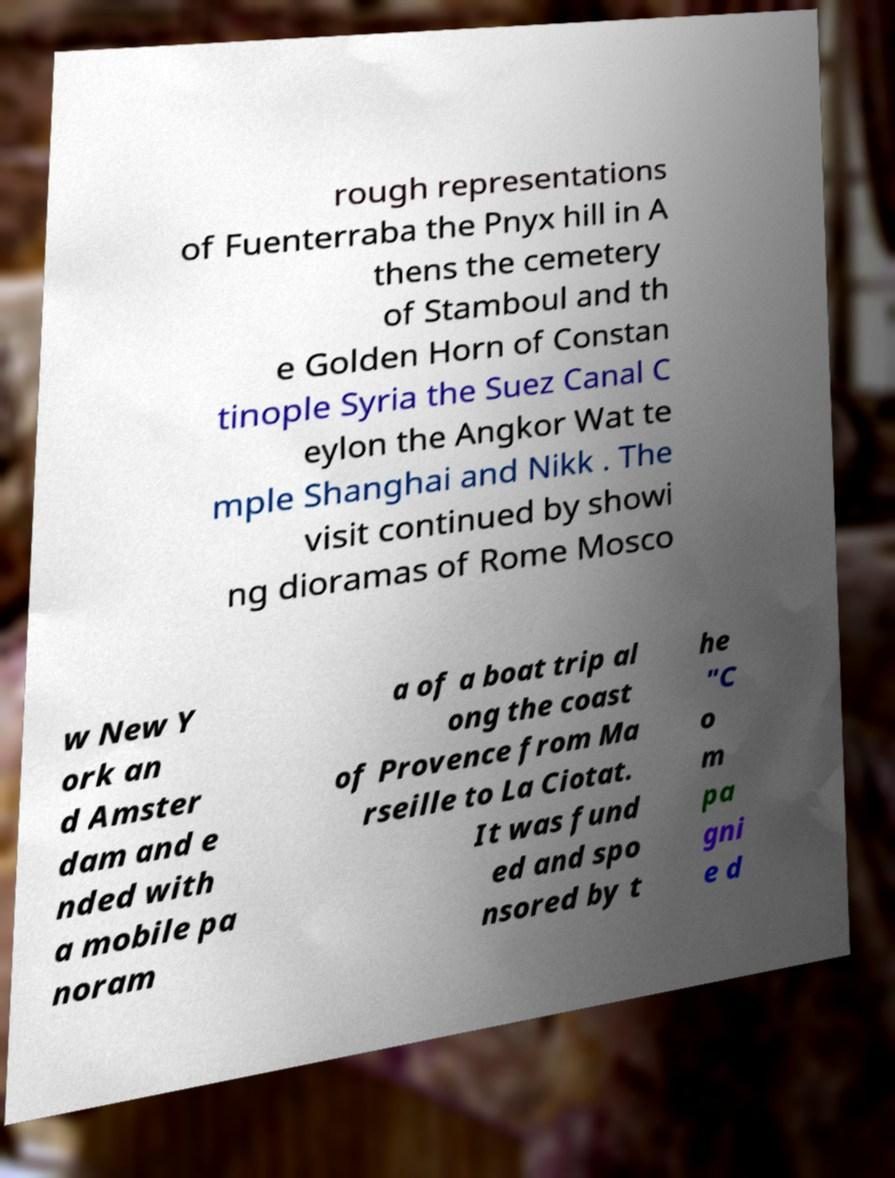I need the written content from this picture converted into text. Can you do that? rough representations of Fuenterraba the Pnyx hill in A thens the cemetery of Stamboul and th e Golden Horn of Constan tinople Syria the Suez Canal C eylon the Angkor Wat te mple Shanghai and Nikk . The visit continued by showi ng dioramas of Rome Mosco w New Y ork an d Amster dam and e nded with a mobile pa noram a of a boat trip al ong the coast of Provence from Ma rseille to La Ciotat. It was fund ed and spo nsored by t he "C o m pa gni e d 